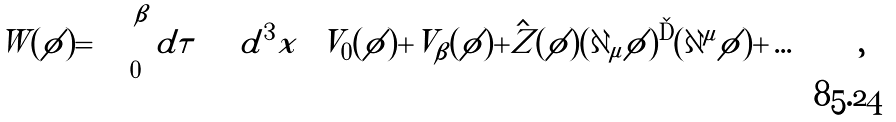<formula> <loc_0><loc_0><loc_500><loc_500>W ( \phi ) = \int _ { 0 } ^ { \beta } d \tau \int d ^ { 3 } x \left [ V _ { 0 } ( | \phi | ) + V _ { \beta } ( | \phi | ) + \hat { Z } ( | \phi | ) ( \partial _ { \mu } \phi ) ^ { \dag } ( \partial ^ { \mu } \phi ) + \dots \right ] \, ,</formula> 